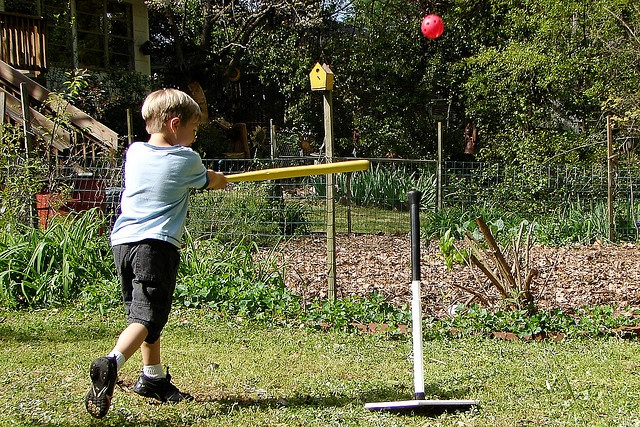Describe the objects in this image and their specific colors. I can see people in black, white, gray, and maroon tones, baseball bat in black, olive, and khaki tones, and sports ball in black, brown, salmon, and lightpink tones in this image. 